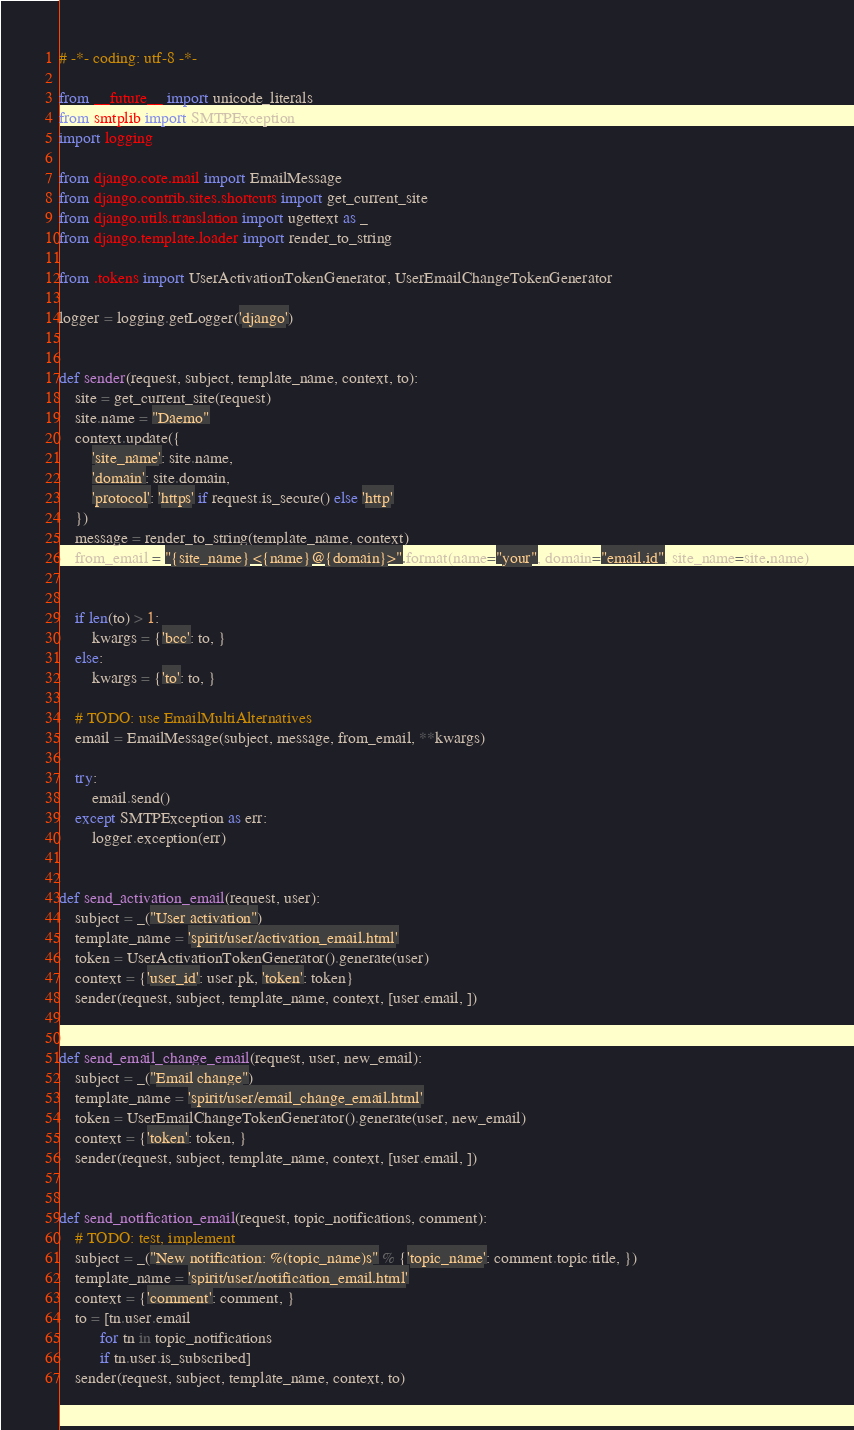Convert code to text. <code><loc_0><loc_0><loc_500><loc_500><_Python_># -*- coding: utf-8 -*-

from __future__ import unicode_literals
from smtplib import SMTPException
import logging

from django.core.mail import EmailMessage
from django.contrib.sites.shortcuts import get_current_site
from django.utils.translation import ugettext as _
from django.template.loader import render_to_string

from .tokens import UserActivationTokenGenerator, UserEmailChangeTokenGenerator

logger = logging.getLogger('django')


def sender(request, subject, template_name, context, to):
    site = get_current_site(request)
    site.name = "Daemo"
    context.update({
        'site_name': site.name,
        'domain': site.domain,
        'protocol': 'https' if request.is_secure() else 'http'
    })
    message = render_to_string(template_name, context)
    from_email = "{site_name} <{name}@{domain}>".format(name="your", domain="email.id", site_name=site.name)


    if len(to) > 1:
        kwargs = {'bcc': to, }
    else:
        kwargs = {'to': to, }

    # TODO: use EmailMultiAlternatives
    email = EmailMessage(subject, message, from_email, **kwargs)

    try:
        email.send()
    except SMTPException as err:
        logger.exception(err)


def send_activation_email(request, user):
    subject = _("User activation")
    template_name = 'spirit/user/activation_email.html'
    token = UserActivationTokenGenerator().generate(user)
    context = {'user_id': user.pk, 'token': token}
    sender(request, subject, template_name, context, [user.email, ])


def send_email_change_email(request, user, new_email):
    subject = _("Email change")
    template_name = 'spirit/user/email_change_email.html'
    token = UserEmailChangeTokenGenerator().generate(user, new_email)
    context = {'token': token, }
    sender(request, subject, template_name, context, [user.email, ])


def send_notification_email(request, topic_notifications, comment):
    # TODO: test, implement
    subject = _("New notification: %(topic_name)s" % {'topic_name': comment.topic.title, })
    template_name = 'spirit/user/notification_email.html'
    context = {'comment': comment, }
    to = [tn.user.email
          for tn in topic_notifications
          if tn.user.is_subscribed]
    sender(request, subject, template_name, context, to)
</code> 